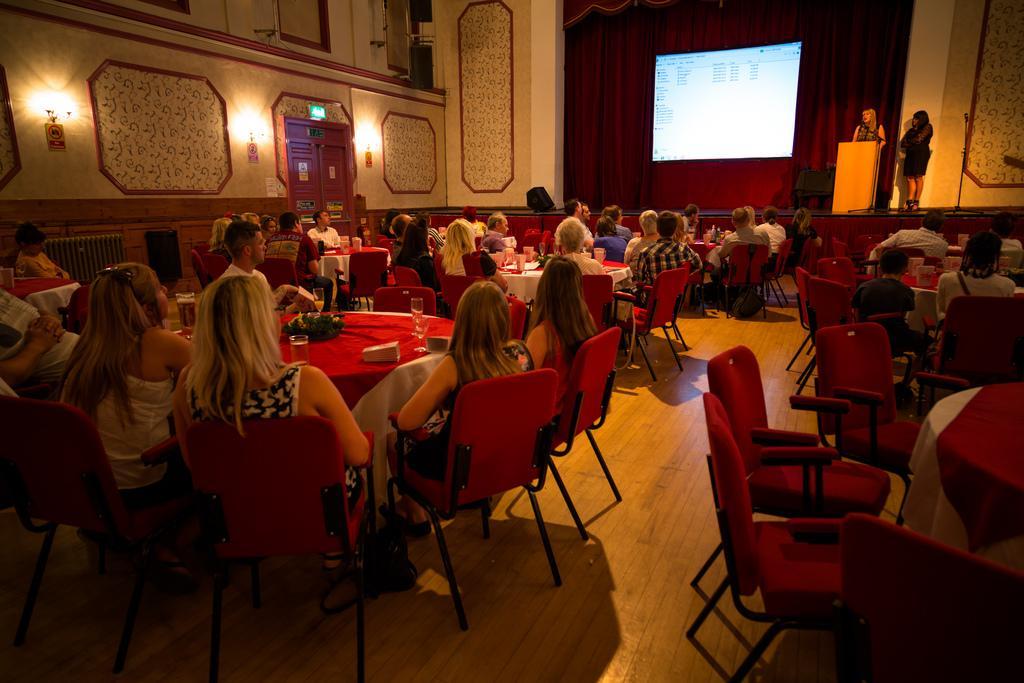Could you give a brief overview of what you see in this image? This is a picture taken in a room, there are a group of people sitting on a chair in front of these people there is a table on the table there are glasses and flowers. In front of this people there is a woman standing behind the podium and a projector screen. Background of this people is a wall with lights. 